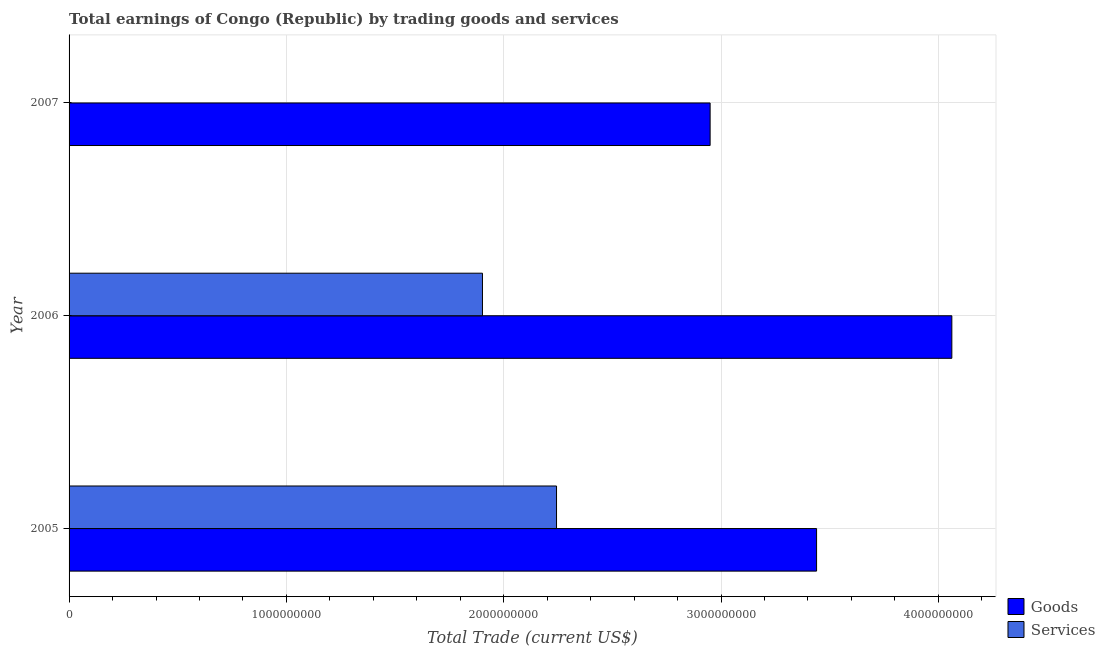How many different coloured bars are there?
Offer a terse response. 2. Are the number of bars per tick equal to the number of legend labels?
Provide a succinct answer. No. Are the number of bars on each tick of the Y-axis equal?
Provide a short and direct response. No. How many bars are there on the 1st tick from the top?
Provide a succinct answer. 1. What is the amount earned by trading goods in 2006?
Give a very brief answer. 4.06e+09. Across all years, what is the maximum amount earned by trading services?
Provide a short and direct response. 2.24e+09. Across all years, what is the minimum amount earned by trading services?
Keep it short and to the point. 0. In which year was the amount earned by trading goods maximum?
Your response must be concise. 2006. What is the total amount earned by trading services in the graph?
Provide a short and direct response. 4.15e+09. What is the difference between the amount earned by trading goods in 2006 and that in 2007?
Make the answer very short. 1.11e+09. What is the difference between the amount earned by trading goods in 2006 and the amount earned by trading services in 2005?
Your answer should be compact. 1.82e+09. What is the average amount earned by trading services per year?
Provide a succinct answer. 1.38e+09. In the year 2005, what is the difference between the amount earned by trading services and amount earned by trading goods?
Ensure brevity in your answer.  -1.20e+09. What is the ratio of the amount earned by trading goods in 2005 to that in 2007?
Your response must be concise. 1.17. Is the amount earned by trading goods in 2005 less than that in 2006?
Provide a succinct answer. Yes. What is the difference between the highest and the second highest amount earned by trading goods?
Provide a short and direct response. 6.22e+08. What is the difference between the highest and the lowest amount earned by trading services?
Ensure brevity in your answer.  2.24e+09. In how many years, is the amount earned by trading services greater than the average amount earned by trading services taken over all years?
Keep it short and to the point. 2. How many years are there in the graph?
Make the answer very short. 3. What is the difference between two consecutive major ticks on the X-axis?
Make the answer very short. 1.00e+09. Are the values on the major ticks of X-axis written in scientific E-notation?
Your answer should be compact. No. Does the graph contain grids?
Offer a terse response. Yes. How many legend labels are there?
Make the answer very short. 2. What is the title of the graph?
Your response must be concise. Total earnings of Congo (Republic) by trading goods and services. What is the label or title of the X-axis?
Your response must be concise. Total Trade (current US$). What is the Total Trade (current US$) in Goods in 2005?
Make the answer very short. 3.44e+09. What is the Total Trade (current US$) of Services in 2005?
Give a very brief answer. 2.24e+09. What is the Total Trade (current US$) in Goods in 2006?
Ensure brevity in your answer.  4.06e+09. What is the Total Trade (current US$) of Services in 2006?
Give a very brief answer. 1.90e+09. What is the Total Trade (current US$) of Goods in 2007?
Give a very brief answer. 2.95e+09. Across all years, what is the maximum Total Trade (current US$) of Goods?
Your answer should be very brief. 4.06e+09. Across all years, what is the maximum Total Trade (current US$) in Services?
Make the answer very short. 2.24e+09. Across all years, what is the minimum Total Trade (current US$) of Goods?
Your answer should be very brief. 2.95e+09. What is the total Total Trade (current US$) of Goods in the graph?
Your answer should be very brief. 1.05e+1. What is the total Total Trade (current US$) in Services in the graph?
Offer a very short reply. 4.15e+09. What is the difference between the Total Trade (current US$) in Goods in 2005 and that in 2006?
Offer a very short reply. -6.22e+08. What is the difference between the Total Trade (current US$) in Services in 2005 and that in 2006?
Give a very brief answer. 3.41e+08. What is the difference between the Total Trade (current US$) in Goods in 2005 and that in 2007?
Your answer should be compact. 4.90e+08. What is the difference between the Total Trade (current US$) in Goods in 2006 and that in 2007?
Offer a terse response. 1.11e+09. What is the difference between the Total Trade (current US$) in Goods in 2005 and the Total Trade (current US$) in Services in 2006?
Your response must be concise. 1.54e+09. What is the average Total Trade (current US$) of Goods per year?
Keep it short and to the point. 3.48e+09. What is the average Total Trade (current US$) in Services per year?
Keep it short and to the point. 1.38e+09. In the year 2005, what is the difference between the Total Trade (current US$) of Goods and Total Trade (current US$) of Services?
Keep it short and to the point. 1.20e+09. In the year 2006, what is the difference between the Total Trade (current US$) in Goods and Total Trade (current US$) in Services?
Your answer should be compact. 2.16e+09. What is the ratio of the Total Trade (current US$) of Goods in 2005 to that in 2006?
Keep it short and to the point. 0.85. What is the ratio of the Total Trade (current US$) in Services in 2005 to that in 2006?
Provide a succinct answer. 1.18. What is the ratio of the Total Trade (current US$) of Goods in 2005 to that in 2007?
Make the answer very short. 1.17. What is the ratio of the Total Trade (current US$) of Goods in 2006 to that in 2007?
Keep it short and to the point. 1.38. What is the difference between the highest and the second highest Total Trade (current US$) in Goods?
Make the answer very short. 6.22e+08. What is the difference between the highest and the lowest Total Trade (current US$) of Goods?
Your answer should be very brief. 1.11e+09. What is the difference between the highest and the lowest Total Trade (current US$) of Services?
Ensure brevity in your answer.  2.24e+09. 